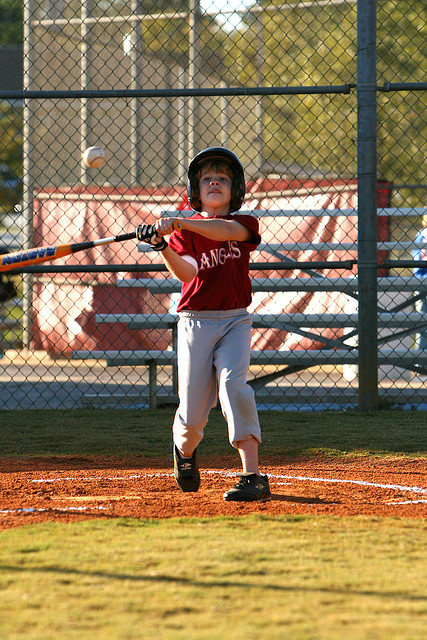Please extract the text content from this image. ANGELS 